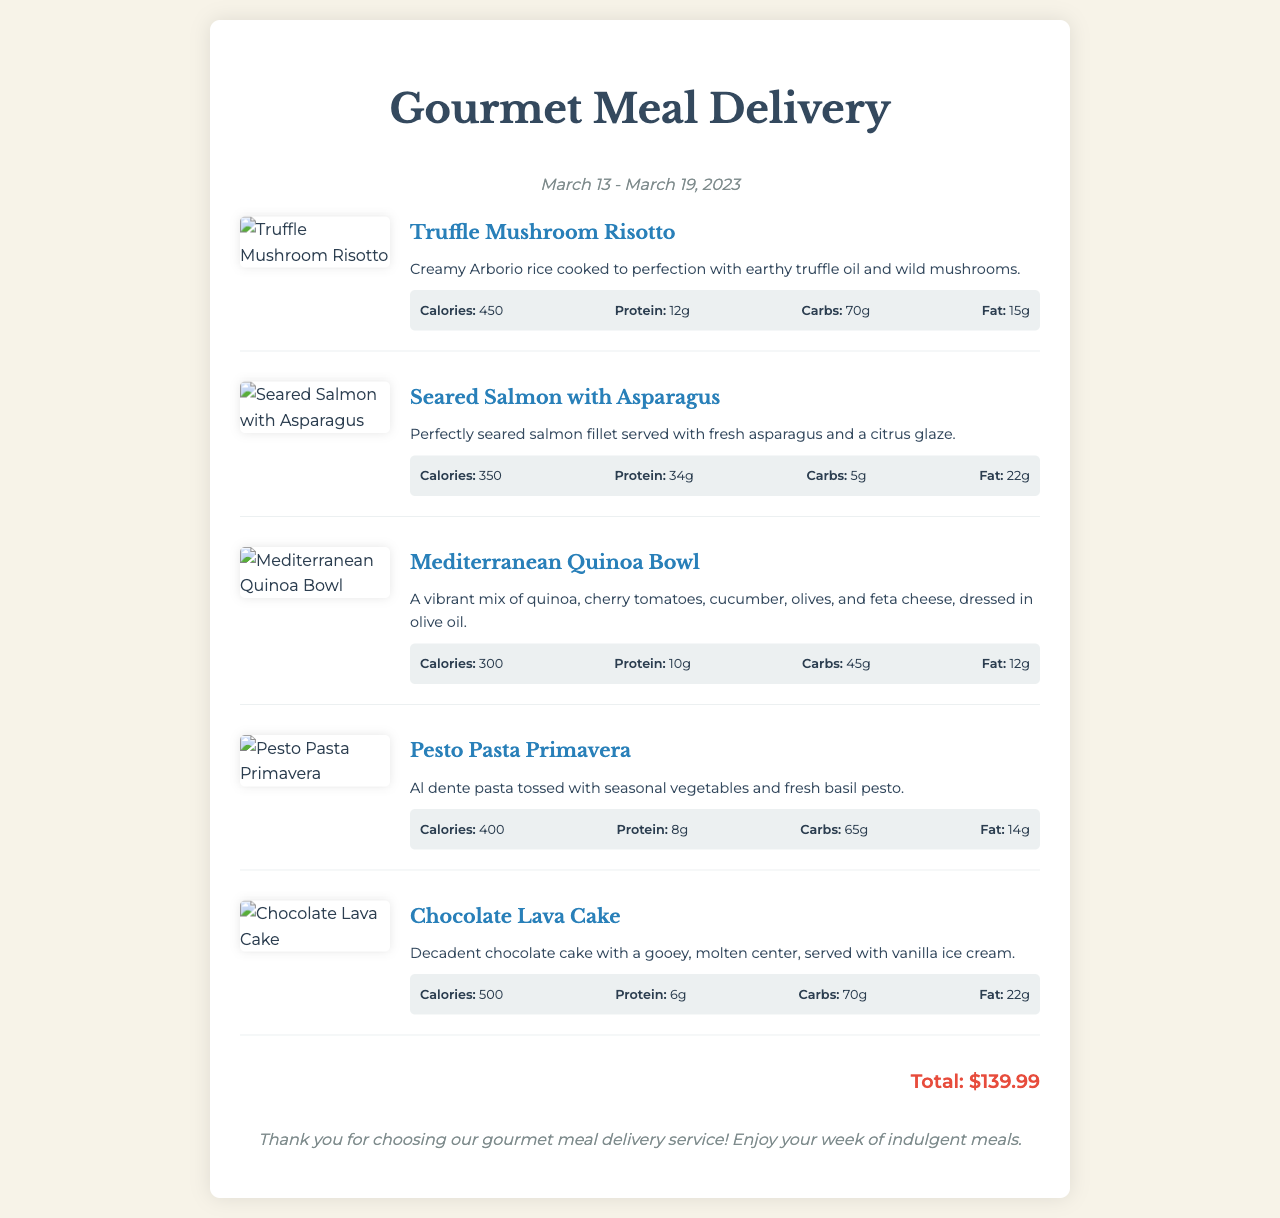What are the dates for the meal delivery week? The dates for the meal delivery week are highlighted under "week-info" in the document.
Answer: March 13 - March 19, 2023 What is the total price of the meals? The total price is presented at the bottom of the receipt and is a key piece of financial information.
Answer: $139.99 How many grams of protein are in the Seared Salmon with Asparagus? This value can be found under the nutritional information for the specific meal.
Answer: 34g What type of dish is the Truffle Mushroom Risotto? The dish name is listed at the top of the section detailing that specific meal.
Answer: Risotto How many calories does the Chocolate Lava Cake contain? The calorie count is provided in the nutritional information section of that particular dish.
Answer: 500 Which meal features a vibrant mix of quinoa? The meal description indicates a blend of ingredients that characterize the dish.
Answer: Mediterranean Quinoa Bowl What is the primary flavor profile of the Pesto Pasta Primavera? The description outlines the key elements and flavor notes of the dish.
Answer: Fresh basil pesto How much fat is in the Mediterranean Quinoa Bowl? This nutritional detail is explicitly stated in the document under the meal's nutritional information.
Answer: 12g What is the visual feature of the meal images? The document's styling emphasizes the presentation of the dish images with specific attributes.
Answer: Appetizing visuals 